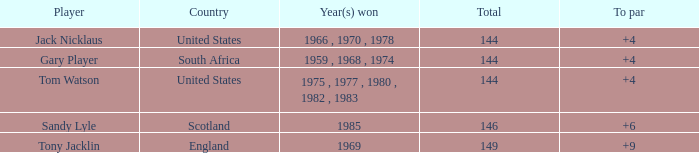What was England's total? 149.0. Would you mind parsing the complete table? {'header': ['Player', 'Country', 'Year(s) won', 'Total', 'To par'], 'rows': [['Jack Nicklaus', 'United States', '1966 , 1970 , 1978', '144', '+4'], ['Gary Player', 'South Africa', '1959 , 1968 , 1974', '144', '+4'], ['Tom Watson', 'United States', '1975 , 1977 , 1980 , 1982 , 1983', '144', '+4'], ['Sandy Lyle', 'Scotland', '1985', '146', '+6'], ['Tony Jacklin', 'England', '1969', '149', '+9']]} 